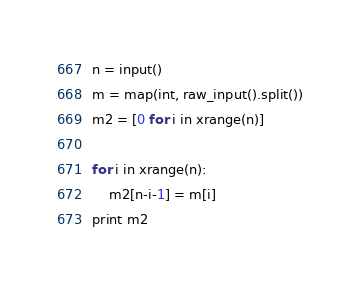<code> <loc_0><loc_0><loc_500><loc_500><_Python_>n = input()
m = map(int, raw_input().split())
m2 = [0 for i in xrange(n)]

for i in xrange(n):
    m2[n-i-1] = m[i]
print m2</code> 